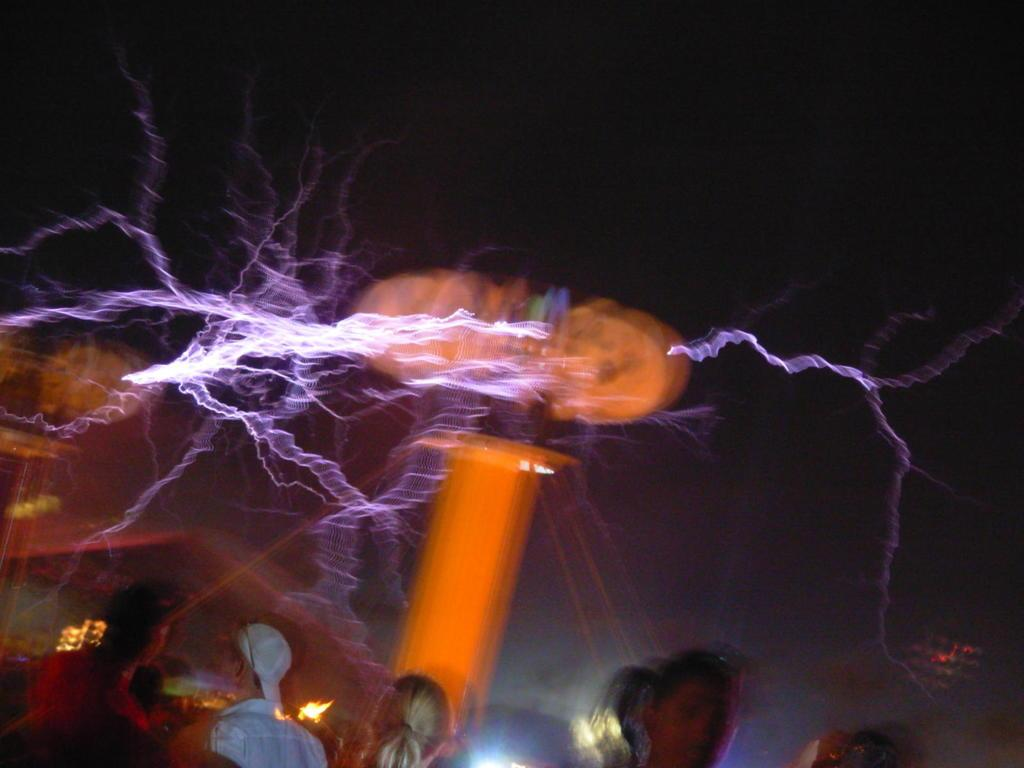What natural phenomenon can be seen in the image? There is lightning in the image. What are the people in the image doing? The people are visible in the image, moving from left to right. What type of flight is taking place in the image? There is no flight present in the image; it features lightning and people moving from left to right. What structure is being lost in the image? There is no structure being lost in the image; it features lightning and people moving from left to right. 